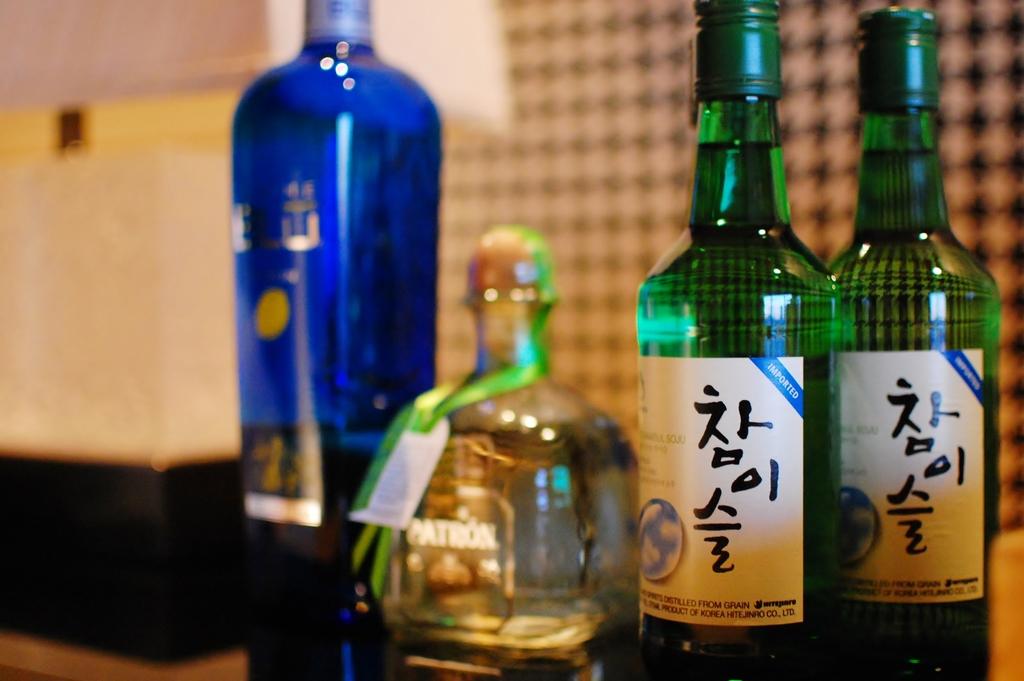Is patron one of the brands?
Ensure brevity in your answer.  Yes. 